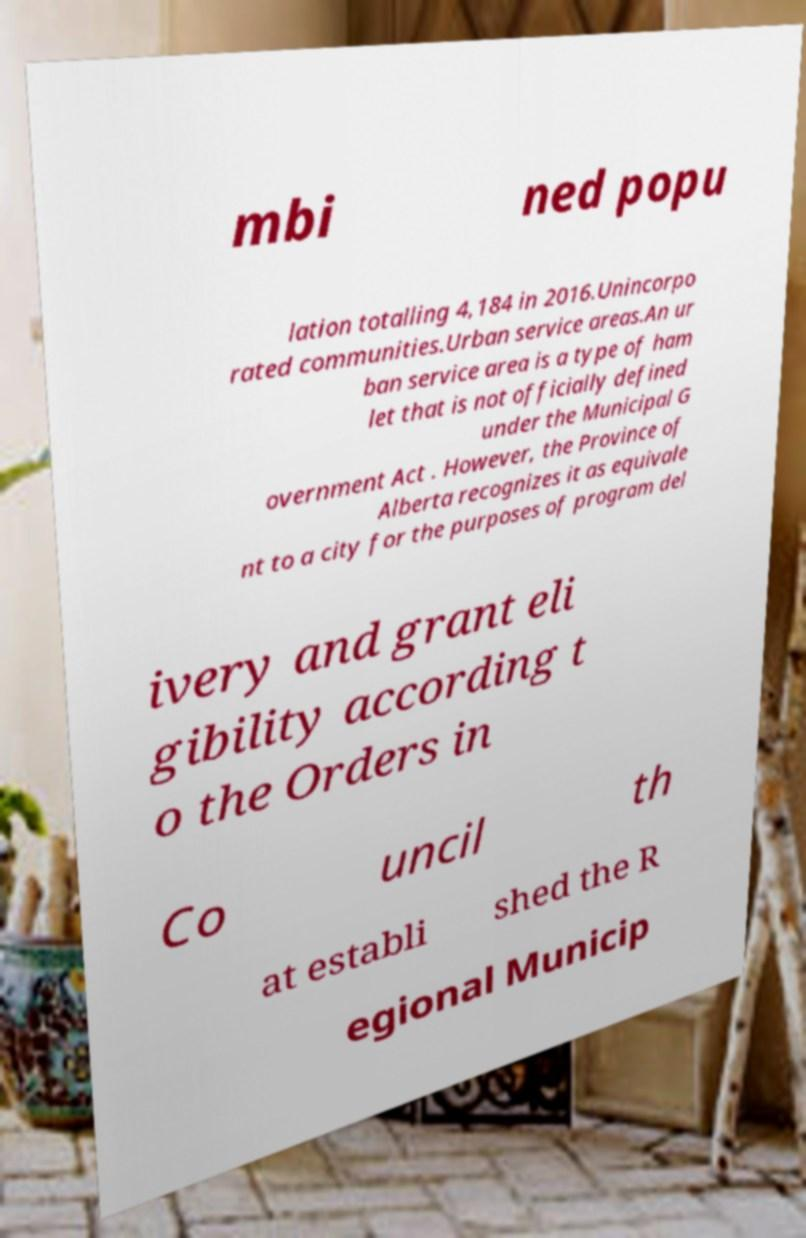There's text embedded in this image that I need extracted. Can you transcribe it verbatim? mbi ned popu lation totalling 4,184 in 2016.Unincorpo rated communities.Urban service areas.An ur ban service area is a type of ham let that is not officially defined under the Municipal G overnment Act . However, the Province of Alberta recognizes it as equivale nt to a city for the purposes of program del ivery and grant eli gibility according t o the Orders in Co uncil th at establi shed the R egional Municip 